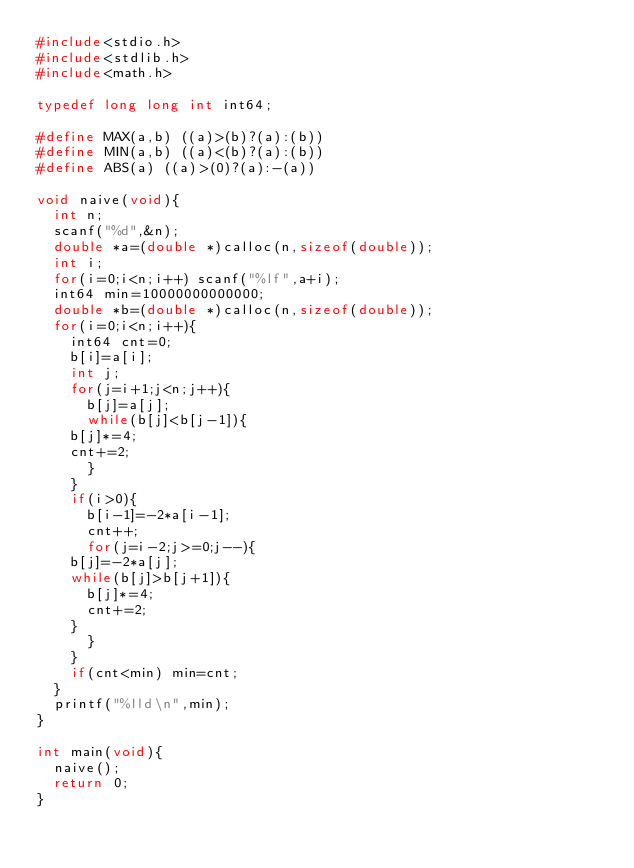Convert code to text. <code><loc_0><loc_0><loc_500><loc_500><_C_>#include<stdio.h>
#include<stdlib.h>
#include<math.h>

typedef long long int int64;

#define MAX(a,b) ((a)>(b)?(a):(b))
#define MIN(a,b) ((a)<(b)?(a):(b))
#define ABS(a) ((a)>(0)?(a):-(a))

void naive(void){
  int n;
  scanf("%d",&n);
  double *a=(double *)calloc(n,sizeof(double));
  int i;
  for(i=0;i<n;i++) scanf("%lf",a+i);
  int64 min=10000000000000;
  double *b=(double *)calloc(n,sizeof(double));
  for(i=0;i<n;i++){
    int64 cnt=0;
    b[i]=a[i];
    int j;
    for(j=i+1;j<n;j++){
      b[j]=a[j];
      while(b[j]<b[j-1]){
	b[j]*=4;
	cnt+=2;
      }
    }
    if(i>0){
      b[i-1]=-2*a[i-1];
      cnt++;
      for(j=i-2;j>=0;j--){
	b[j]=-2*a[j];
	while(b[j]>b[j+1]){
	  b[j]*=4;
	  cnt+=2;
	}
      }
    }
    if(cnt<min) min=cnt;
  }
  printf("%lld\n",min);
}

int main(void){
  naive();
  return 0;
}
</code> 